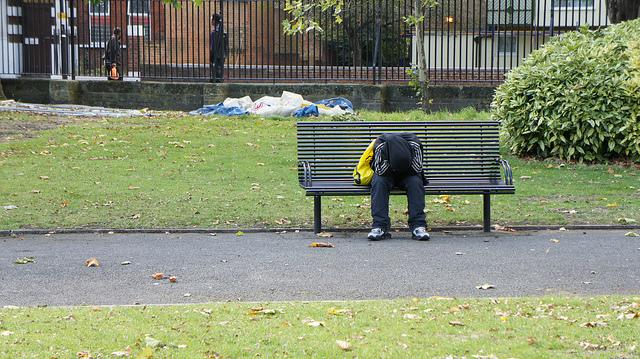Where were the first free public benches invented? Please explain your reasoning. france. France came out with free public benches. 